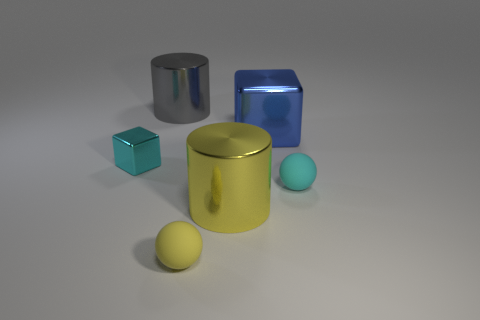Subtract 1 spheres. How many spheres are left? 1 Add 1 tiny gray matte blocks. How many objects exist? 7 Subtract 0 purple cubes. How many objects are left? 6 Subtract all cylinders. How many objects are left? 4 Subtract all cyan cubes. Subtract all brown spheres. How many cubes are left? 1 Subtract all red spheres. How many cyan cubes are left? 1 Subtract all metal things. Subtract all large purple rubber objects. How many objects are left? 2 Add 1 cyan rubber objects. How many cyan rubber objects are left? 2 Add 3 metal balls. How many metal balls exist? 3 